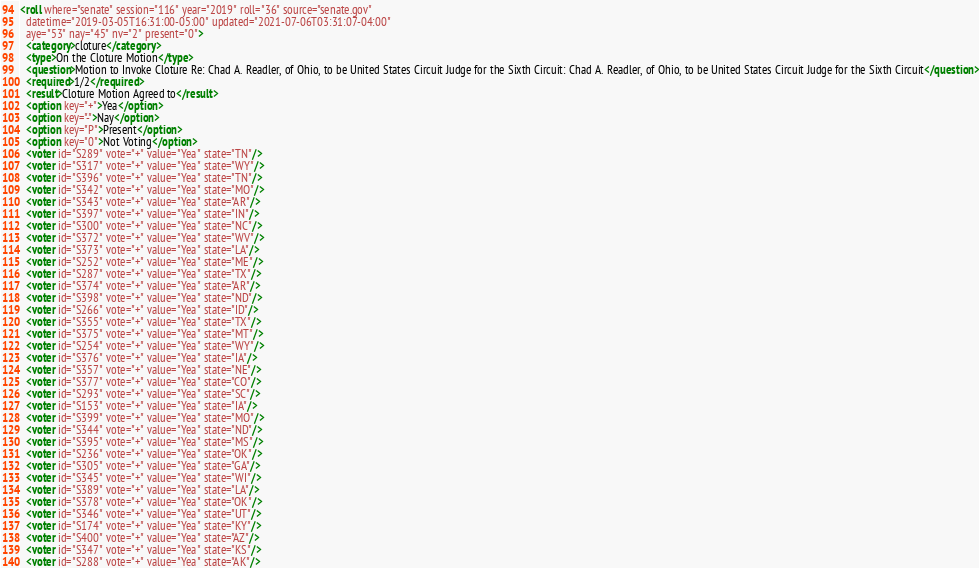Convert code to text. <code><loc_0><loc_0><loc_500><loc_500><_XML_><roll where="senate" session="116" year="2019" roll="36" source="senate.gov"
  datetime="2019-03-05T16:31:00-05:00" updated="2021-07-06T03:31:07-04:00"
  aye="53" nay="45" nv="2" present="0">
  <category>cloture</category>
  <type>On the Cloture Motion</type>
  <question>Motion to Invoke Cloture Re: Chad A. Readler, of Ohio, to be United States Circuit Judge for the Sixth Circuit: Chad A. Readler, of Ohio, to be United States Circuit Judge for the Sixth Circuit</question>
  <required>1/2</required>
  <result>Cloture Motion Agreed to</result>
  <option key="+">Yea</option>
  <option key="-">Nay</option>
  <option key="P">Present</option>
  <option key="0">Not Voting</option>
  <voter id="S289" vote="+" value="Yea" state="TN"/>
  <voter id="S317" vote="+" value="Yea" state="WY"/>
  <voter id="S396" vote="+" value="Yea" state="TN"/>
  <voter id="S342" vote="+" value="Yea" state="MO"/>
  <voter id="S343" vote="+" value="Yea" state="AR"/>
  <voter id="S397" vote="+" value="Yea" state="IN"/>
  <voter id="S300" vote="+" value="Yea" state="NC"/>
  <voter id="S372" vote="+" value="Yea" state="WV"/>
  <voter id="S373" vote="+" value="Yea" state="LA"/>
  <voter id="S252" vote="+" value="Yea" state="ME"/>
  <voter id="S287" vote="+" value="Yea" state="TX"/>
  <voter id="S374" vote="+" value="Yea" state="AR"/>
  <voter id="S398" vote="+" value="Yea" state="ND"/>
  <voter id="S266" vote="+" value="Yea" state="ID"/>
  <voter id="S355" vote="+" value="Yea" state="TX"/>
  <voter id="S375" vote="+" value="Yea" state="MT"/>
  <voter id="S254" vote="+" value="Yea" state="WY"/>
  <voter id="S376" vote="+" value="Yea" state="IA"/>
  <voter id="S357" vote="+" value="Yea" state="NE"/>
  <voter id="S377" vote="+" value="Yea" state="CO"/>
  <voter id="S293" vote="+" value="Yea" state="SC"/>
  <voter id="S153" vote="+" value="Yea" state="IA"/>
  <voter id="S399" vote="+" value="Yea" state="MO"/>
  <voter id="S344" vote="+" value="Yea" state="ND"/>
  <voter id="S395" vote="+" value="Yea" state="MS"/>
  <voter id="S236" vote="+" value="Yea" state="OK"/>
  <voter id="S305" vote="+" value="Yea" state="GA"/>
  <voter id="S345" vote="+" value="Yea" state="WI"/>
  <voter id="S389" vote="+" value="Yea" state="LA"/>
  <voter id="S378" vote="+" value="Yea" state="OK"/>
  <voter id="S346" vote="+" value="Yea" state="UT"/>
  <voter id="S174" vote="+" value="Yea" state="KY"/>
  <voter id="S400" vote="+" value="Yea" state="AZ"/>
  <voter id="S347" vote="+" value="Yea" state="KS"/>
  <voter id="S288" vote="+" value="Yea" state="AK"/></code> 